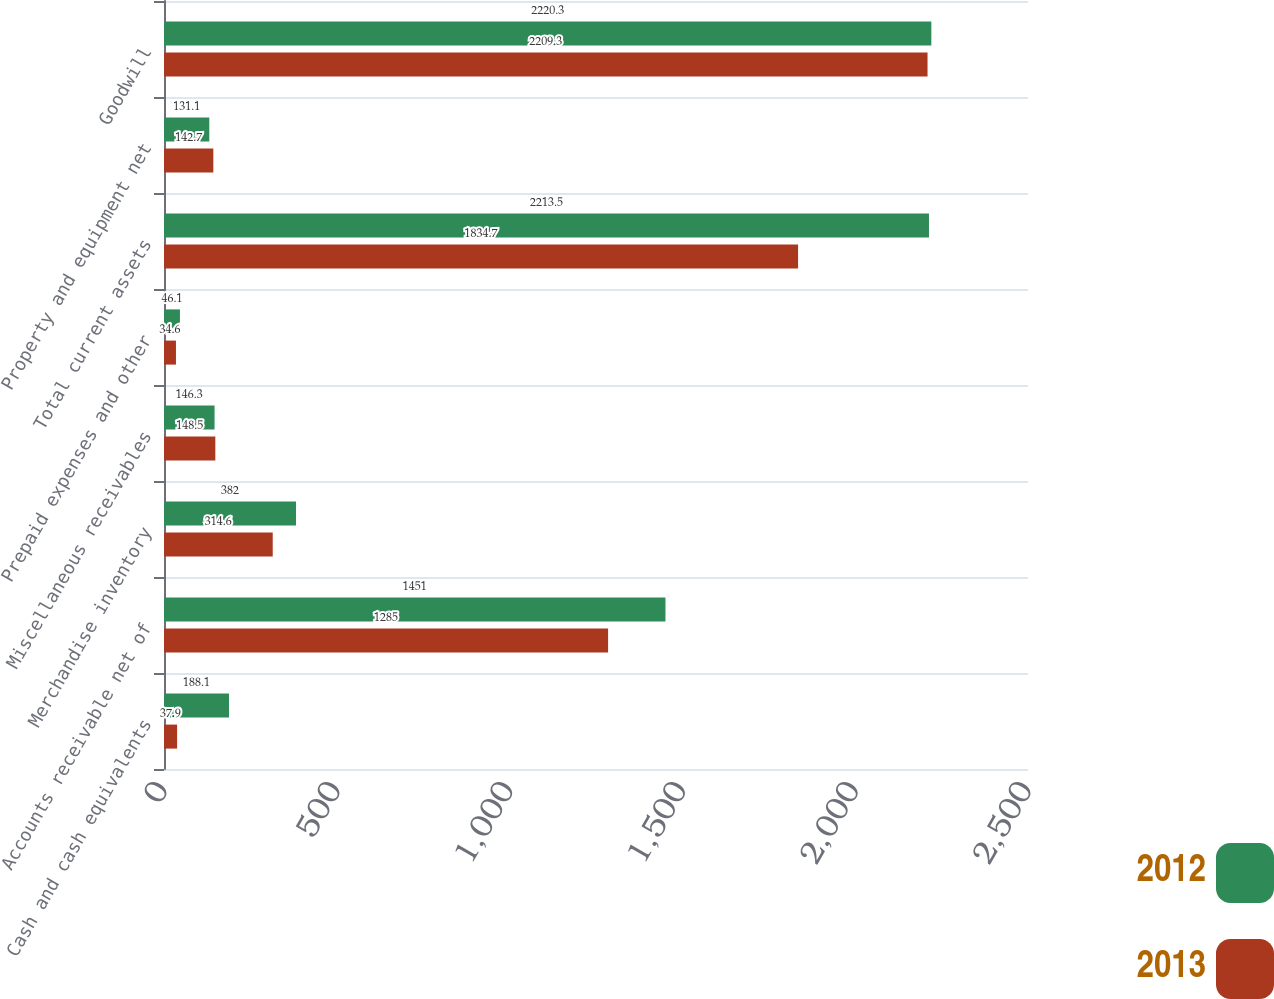Convert chart to OTSL. <chart><loc_0><loc_0><loc_500><loc_500><stacked_bar_chart><ecel><fcel>Cash and cash equivalents<fcel>Accounts receivable net of<fcel>Merchandise inventory<fcel>Miscellaneous receivables<fcel>Prepaid expenses and other<fcel>Total current assets<fcel>Property and equipment net<fcel>Goodwill<nl><fcel>2012<fcel>188.1<fcel>1451<fcel>382<fcel>146.3<fcel>46.1<fcel>2213.5<fcel>131.1<fcel>2220.3<nl><fcel>2013<fcel>37.9<fcel>1285<fcel>314.6<fcel>148.5<fcel>34.6<fcel>1834.7<fcel>142.7<fcel>2209.3<nl></chart> 